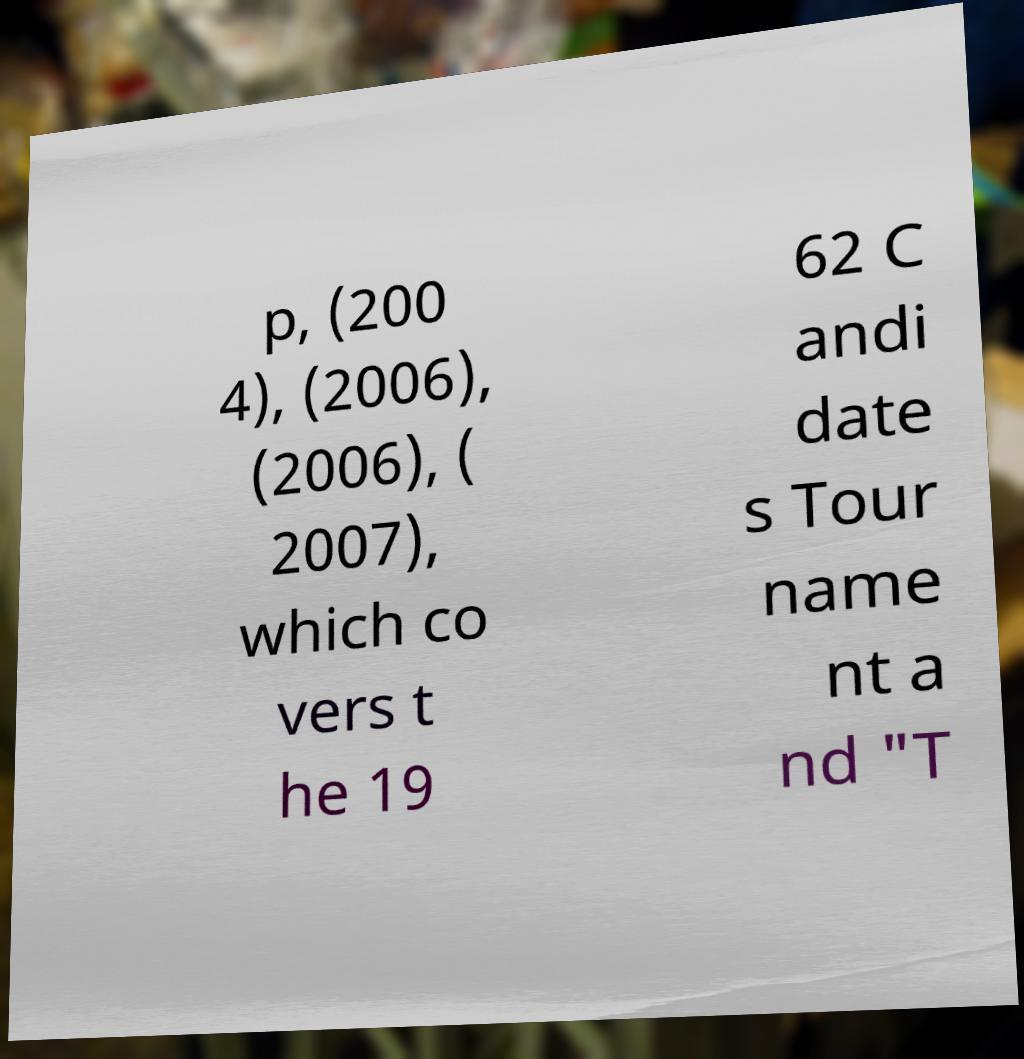Please identify and transcribe the text found in this image. p, (200 4), (2006), (2006), ( 2007), which co vers t he 19 62 C andi date s Tour name nt a nd "T 